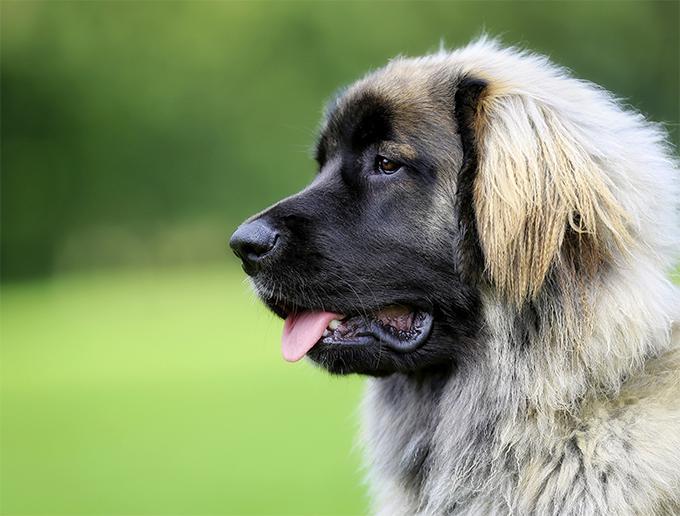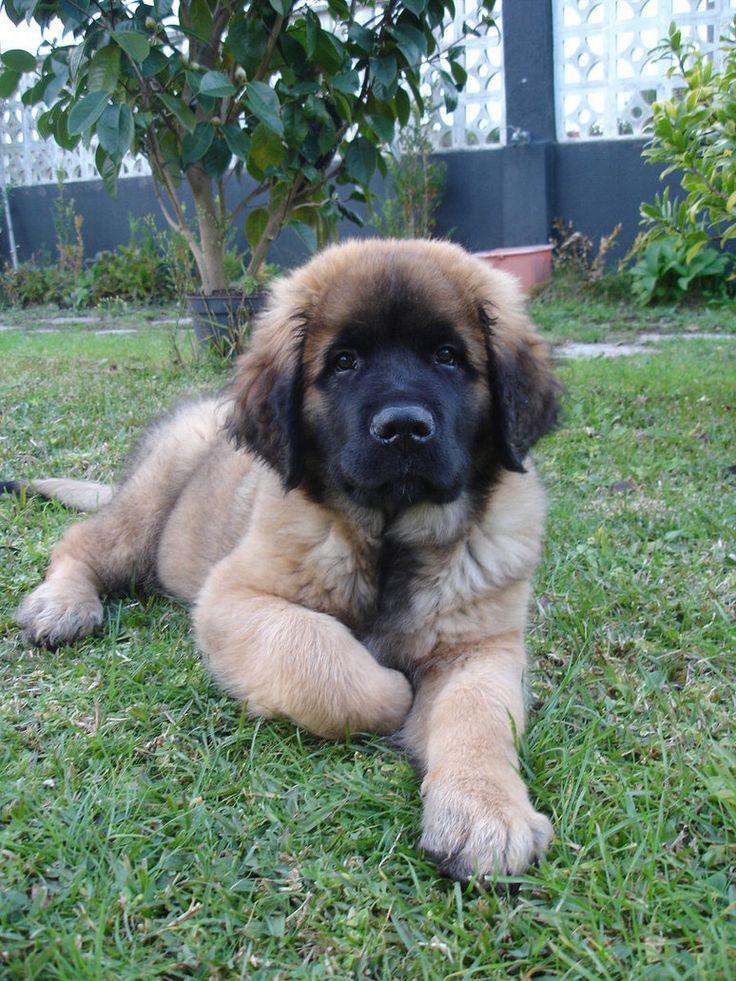The first image is the image on the left, the second image is the image on the right. For the images displayed, is the sentence "One image contains just one dog, which is standing on all fours." factually correct? Answer yes or no. No. The first image is the image on the left, the second image is the image on the right. For the images shown, is this caption "At least one of the dogs in the image on the left is shown standing up on the ground." true? Answer yes or no. No. 